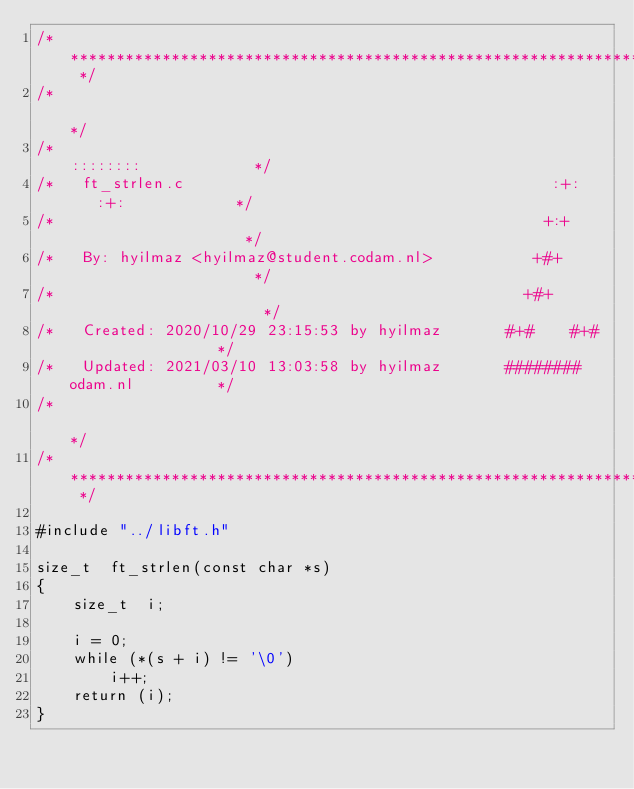<code> <loc_0><loc_0><loc_500><loc_500><_C_>/* ************************************************************************** */
/*                                                                            */
/*                                                        ::::::::            */
/*   ft_strlen.c                                        :+:    :+:            */
/*                                                     +:+                    */
/*   By: hyilmaz <hyilmaz@student.codam.nl>           +#+                     */
/*                                                   +#+                      */
/*   Created: 2020/10/29 23:15:53 by hyilmaz       #+#    #+#                 */
/*   Updated: 2021/03/10 13:03:58 by hyilmaz       ########   odam.nl         */
/*                                                                            */
/* ************************************************************************** */

#include "../libft.h"

size_t	ft_strlen(const char *s)
{
	size_t	i;

	i = 0;
	while (*(s + i) != '\0')
		i++;
	return (i);
}
</code> 